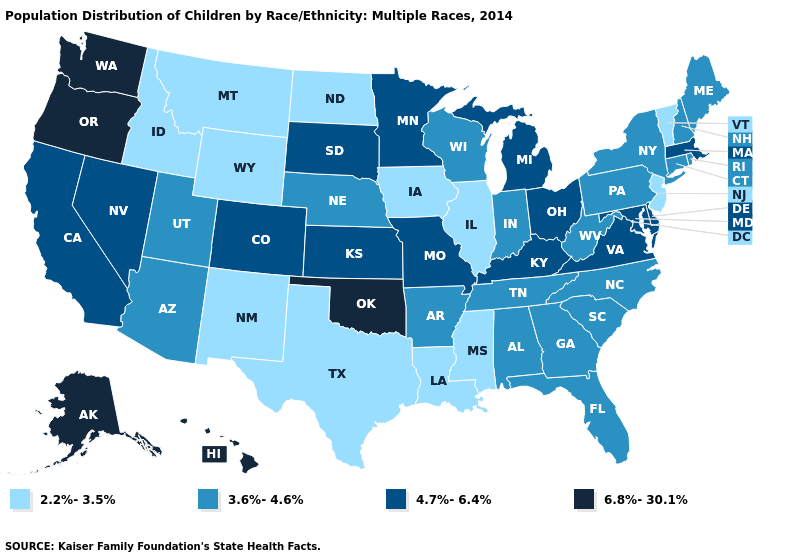Name the states that have a value in the range 3.6%-4.6%?
Short answer required. Alabama, Arizona, Arkansas, Connecticut, Florida, Georgia, Indiana, Maine, Nebraska, New Hampshire, New York, North Carolina, Pennsylvania, Rhode Island, South Carolina, Tennessee, Utah, West Virginia, Wisconsin. What is the highest value in the MidWest ?
Concise answer only. 4.7%-6.4%. What is the value of Minnesota?
Be succinct. 4.7%-6.4%. Name the states that have a value in the range 4.7%-6.4%?
Short answer required. California, Colorado, Delaware, Kansas, Kentucky, Maryland, Massachusetts, Michigan, Minnesota, Missouri, Nevada, Ohio, South Dakota, Virginia. How many symbols are there in the legend?
Be succinct. 4. Name the states that have a value in the range 3.6%-4.6%?
Short answer required. Alabama, Arizona, Arkansas, Connecticut, Florida, Georgia, Indiana, Maine, Nebraska, New Hampshire, New York, North Carolina, Pennsylvania, Rhode Island, South Carolina, Tennessee, Utah, West Virginia, Wisconsin. Does Minnesota have the lowest value in the MidWest?
Keep it brief. No. What is the value of Alabama?
Quick response, please. 3.6%-4.6%. What is the lowest value in the Northeast?
Quick response, please. 2.2%-3.5%. What is the lowest value in the USA?
Answer briefly. 2.2%-3.5%. What is the value of Hawaii?
Quick response, please. 6.8%-30.1%. What is the highest value in states that border Iowa?
Concise answer only. 4.7%-6.4%. Does New Hampshire have the highest value in the USA?
Be succinct. No. Does Alaska have the highest value in the USA?
Give a very brief answer. Yes. What is the lowest value in the South?
Short answer required. 2.2%-3.5%. 